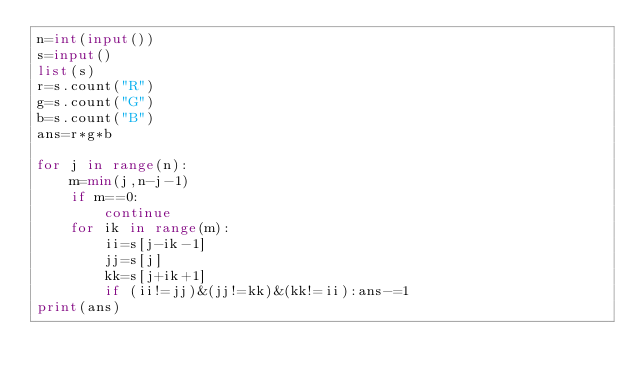<code> <loc_0><loc_0><loc_500><loc_500><_Python_>n=int(input())
s=input()
list(s)
r=s.count("R")
g=s.count("G")
b=s.count("B")
ans=r*g*b

for j in range(n):
    m=min(j,n-j-1)
    if m==0:
        continue
    for ik in range(m):
        ii=s[j-ik-1]
        jj=s[j]
        kk=s[j+ik+1]
        if (ii!=jj)&(jj!=kk)&(kk!=ii):ans-=1
print(ans)</code> 